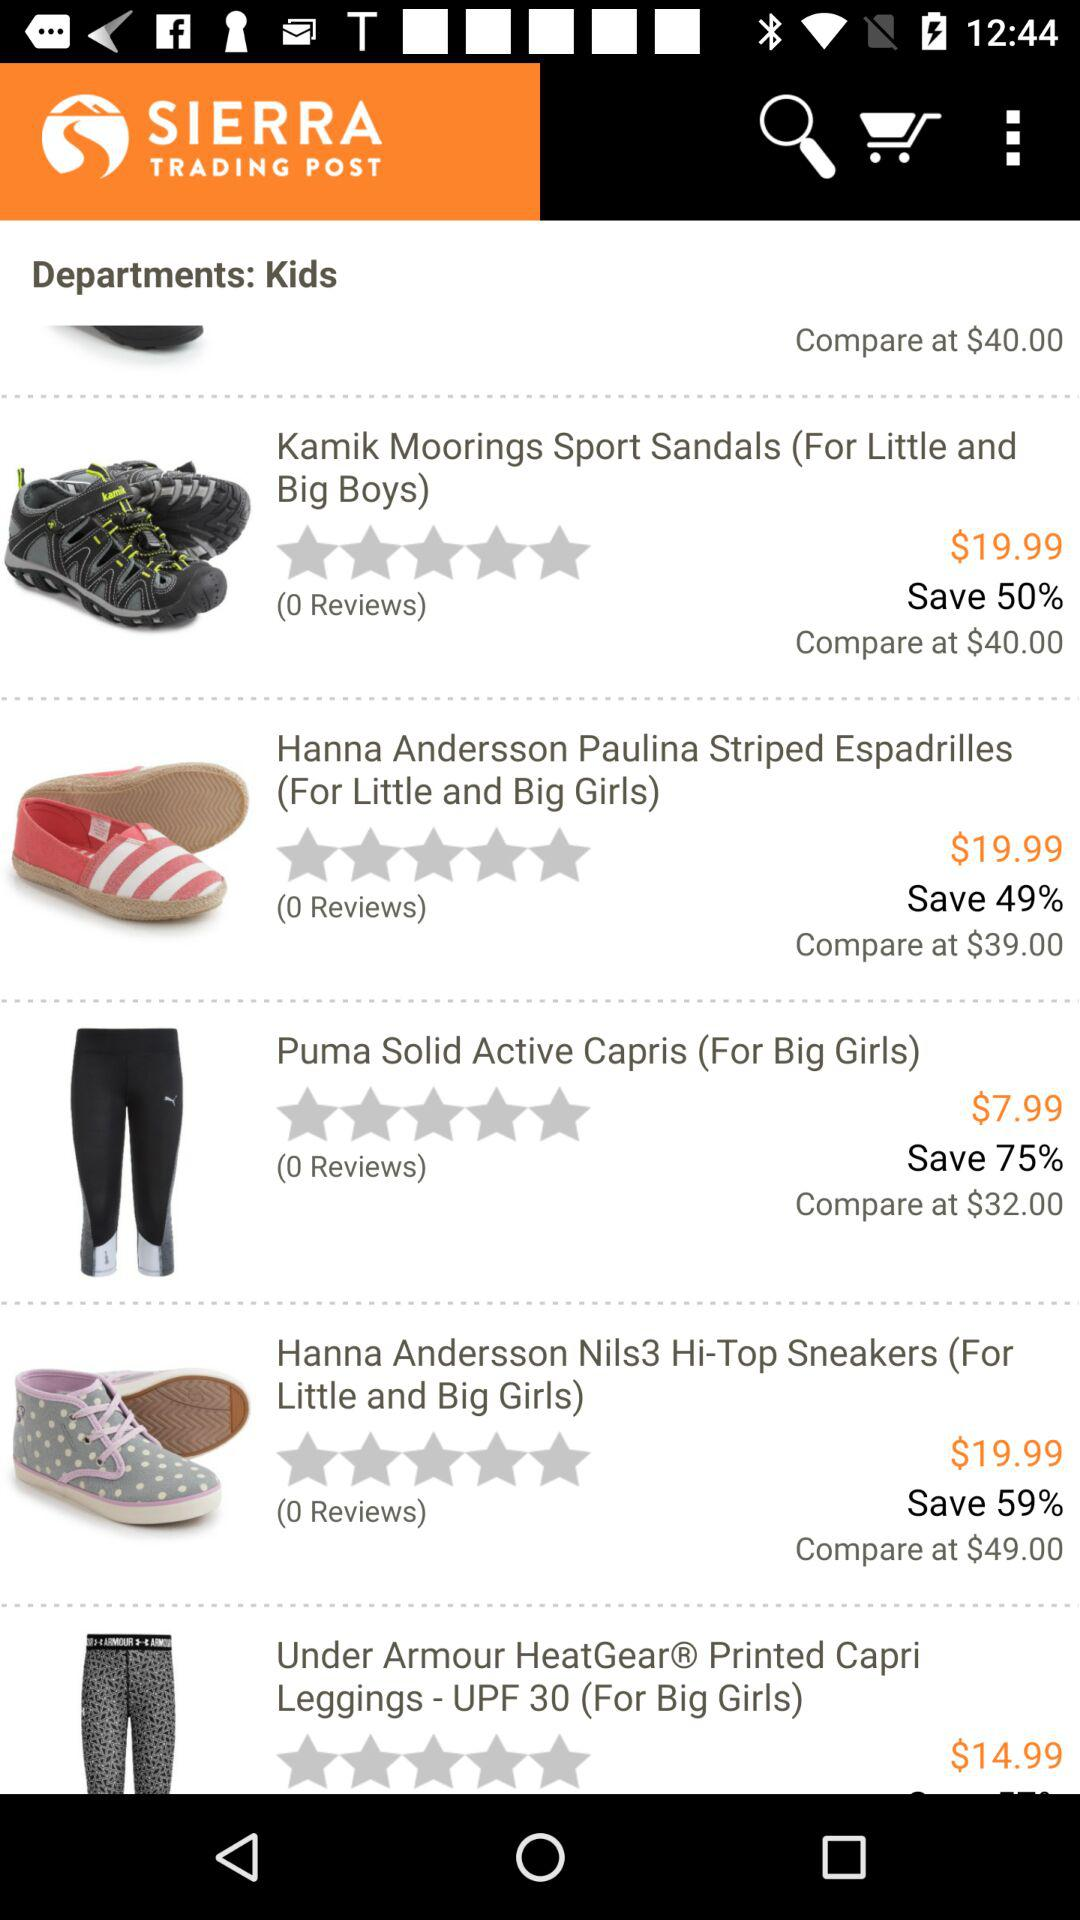What's the price of the "Puma Solid Active Capris"? The price of the "Puma Solid Active Capris" is $7.99. 